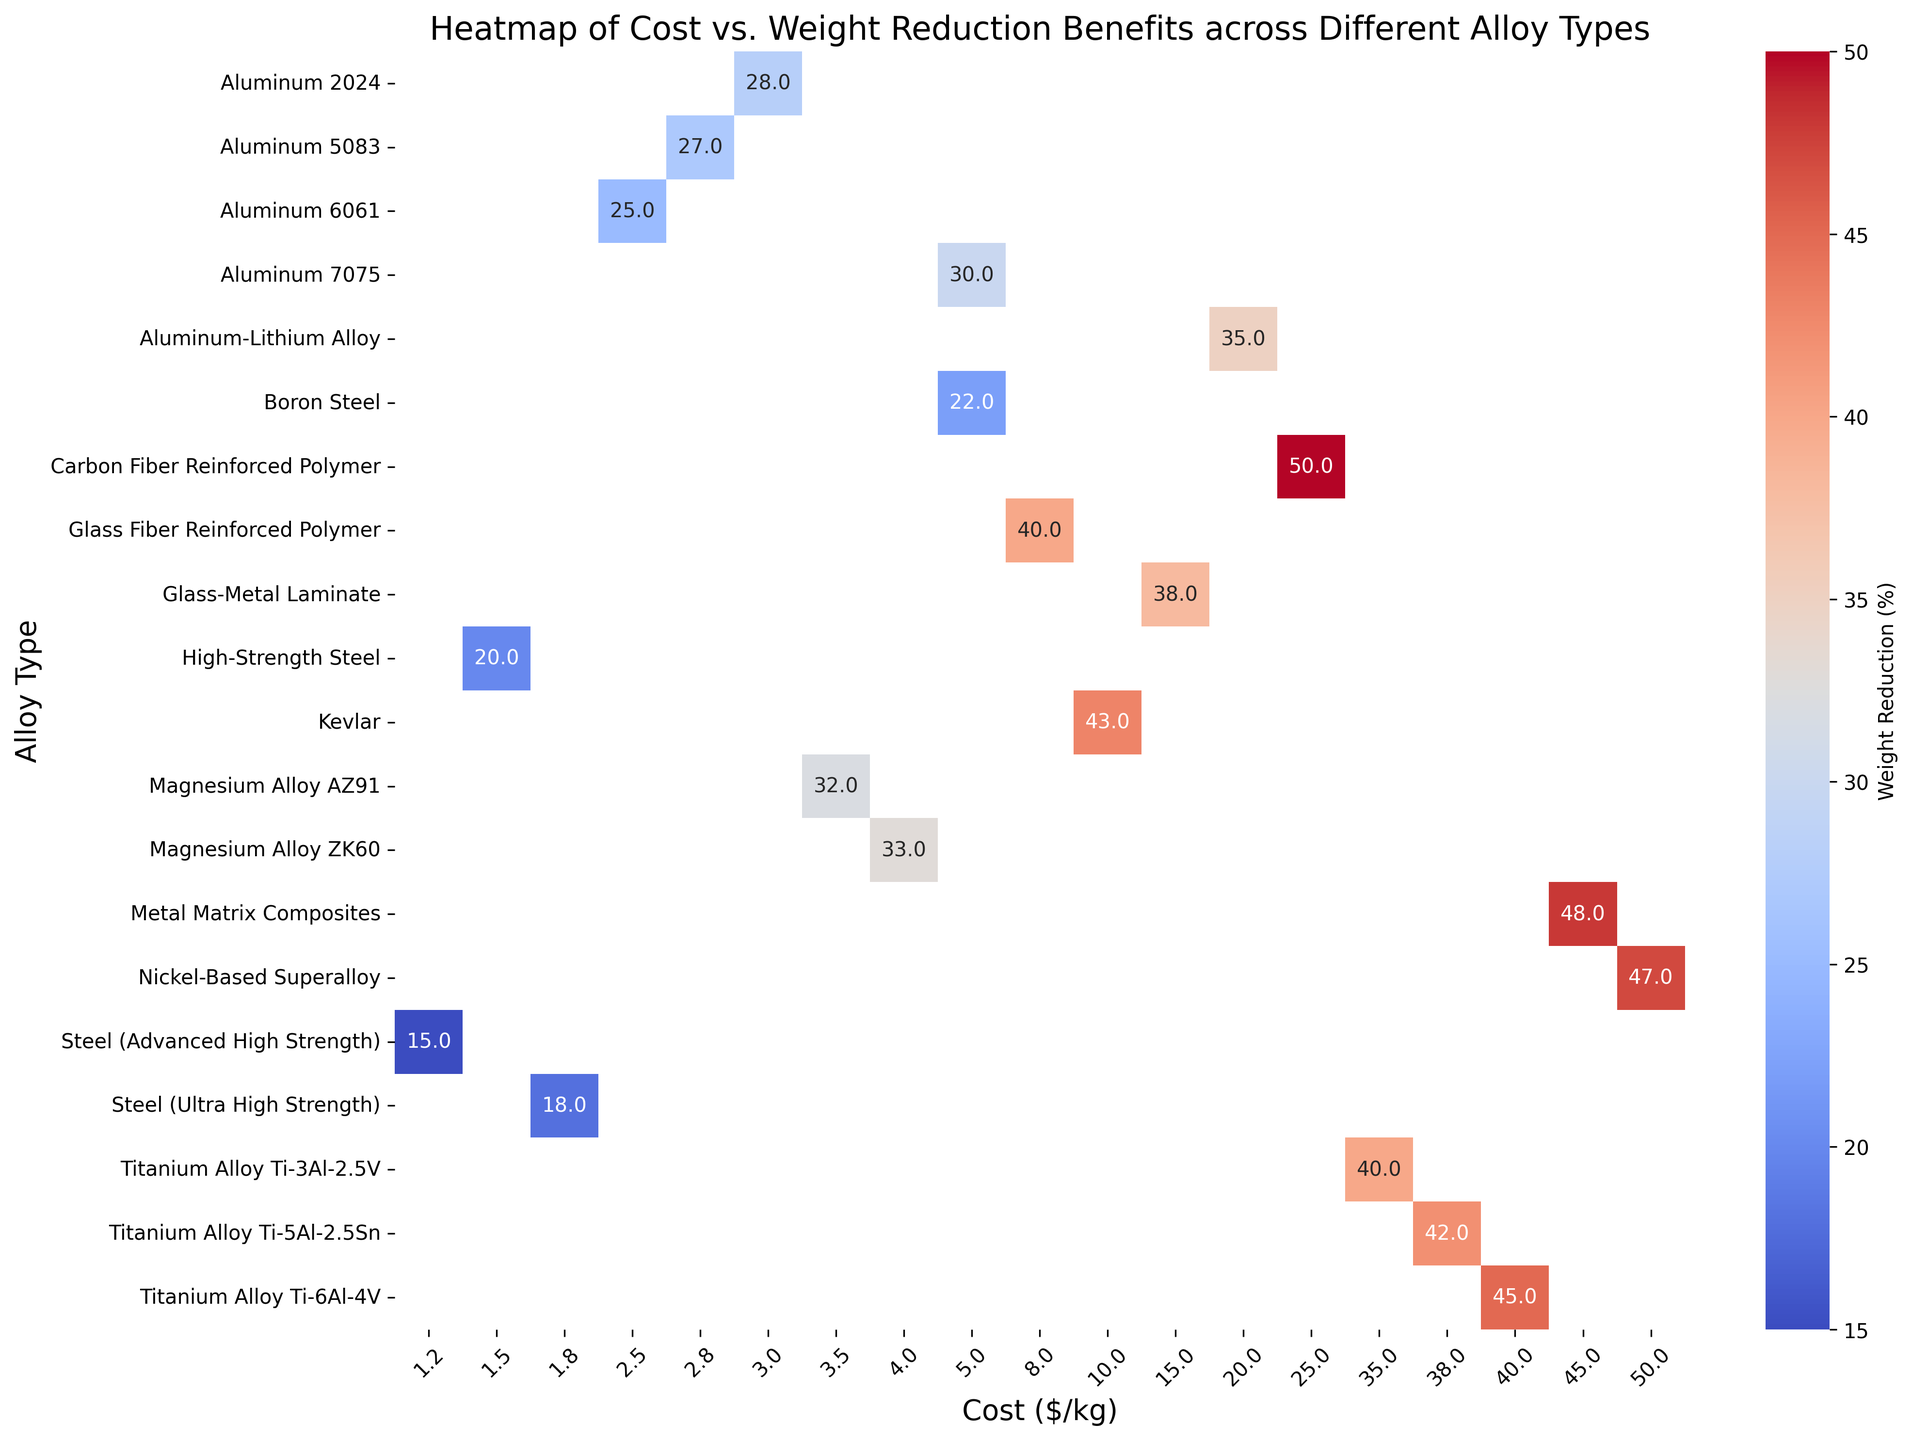What's the most cost-effective alloy with at least 30% weight reduction? To find the most cost-effective alloy with at least 30% weight reduction, look at the alloys along the y-axis and scan for those with weight reductions 30% or higher. Among those, identify the alloy with the lowest cost per kg on the x-axis.
Answer: Aluminum 7075 Which alloy provides the maximum weight reduction, and what is its cost? Locate the cell with the highest percentage value on the heatmap which represents weight reduction. Then look at the corresponding alloy type and cost.
Answer: Carbon Fiber Reinforced Polymer, $25.0/kg Is there a significant difference in cost between the alloy with the highest weight reduction and the alloy with the lowest weight reduction? Identify the alloys with the highest and lowest weight reduction values. Then, compare their costs from the x-axis values. The largest weight reduction percentage is 50% (Carbon Fiber Reinforced Polymer at $25.0/kg) and the smallest is 15% (Steel (Advanced High Strength) at $1.2/kg). Calculate the difference:
Answer: Yes, $23.8/kg Which alloys are priced above $20/kg but provide less than 40% weight reduction? Check the y-axis for alloys priced above $20/kg and then scan across to see if their weight reduction values are less than 40%. These are: Nickel-Based Superalloy (47%), Metal Matrix Composites (48%), and Kevlar (43%). So, there are no alloys in this group.
Answer: None What is the average weight reduction percentage for alloys costing less than $5/kg? Identify the alloy types costing less than $5/kg, which are Aluminum 6061, Aluminum 7075, Magnesium Alloy AZ91, Steel (Advanced High Strength), Aluminum 2024, Aluminum 5083, Magnesium Alloy ZK60, High-Strength Steel, and Steel (Ultra High Strength). Sum their weight reduction percentages and divide by the number of alloys: (25 + 30 + 32 + 15 + 28 + 27 + 33 + 20 + 18)/9 = 22.1%
Answer: 22.1% How does the weight reduction of High-Strength Steel compare to that of Ultra High Strength Steel? Identify the weight reduction percentages for High-Strength Steel (20%) and Ultra High Strength Steel (18%) on the y-axis. Compare these values.
Answer: High-Strength Steel has a 2% higher weight reduction than Ultra High Strength Steel Which alloy type has a higher weight reduction percentage, Magnesium Alloy AZ91 or Magnesium Alloy ZK60? Identify both magnesium alloys on the heatmap, then compare their weight reduction percentages. Magnesium Alloy AZ91 has 32% and Magnesium Alloy ZK60 has 33%.
Answer: Magnesium Alloy ZK60 Considering both cost and weight reduction percentage, which alloy stands out as the best balanced? Scan the heatmap to find the alloy that offers a good balance of lower cost and higher weight reduction. A reasonable pick is Aluminum 7075, with a cost of $5.0/kg and a weight reduction of 30%.
Answer: Aluminum 7075 What is the range of weight reductions among the alloys with costs between $1.0/kg and $10.0/kg? Identify the alloys within the $1.0/kg to $10.0/kg cost range and note their weight reduction percentages: Steel (Advanced High Strength) 15%, High-Strength Steel 20%, Steel (Ultra High Strength) 18%, Aluminum 6061 25%, Aluminum 7075 30%, Aluminum 2024 28%, Magnesium Alloy AZ91 32%, Magnesium Alloy ZK60 33%, Boron Steel 22%, Glass Fiber Reinforced Polymer 40%. The range is the difference between the highest and lowest percentages within this group.
Answer: 25% 